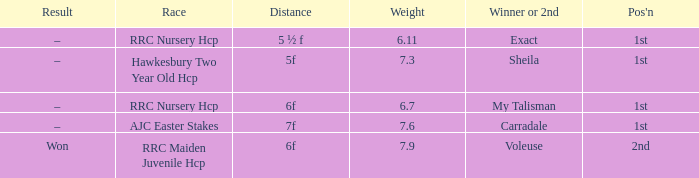3, and the conclusion was –? Carradale. 